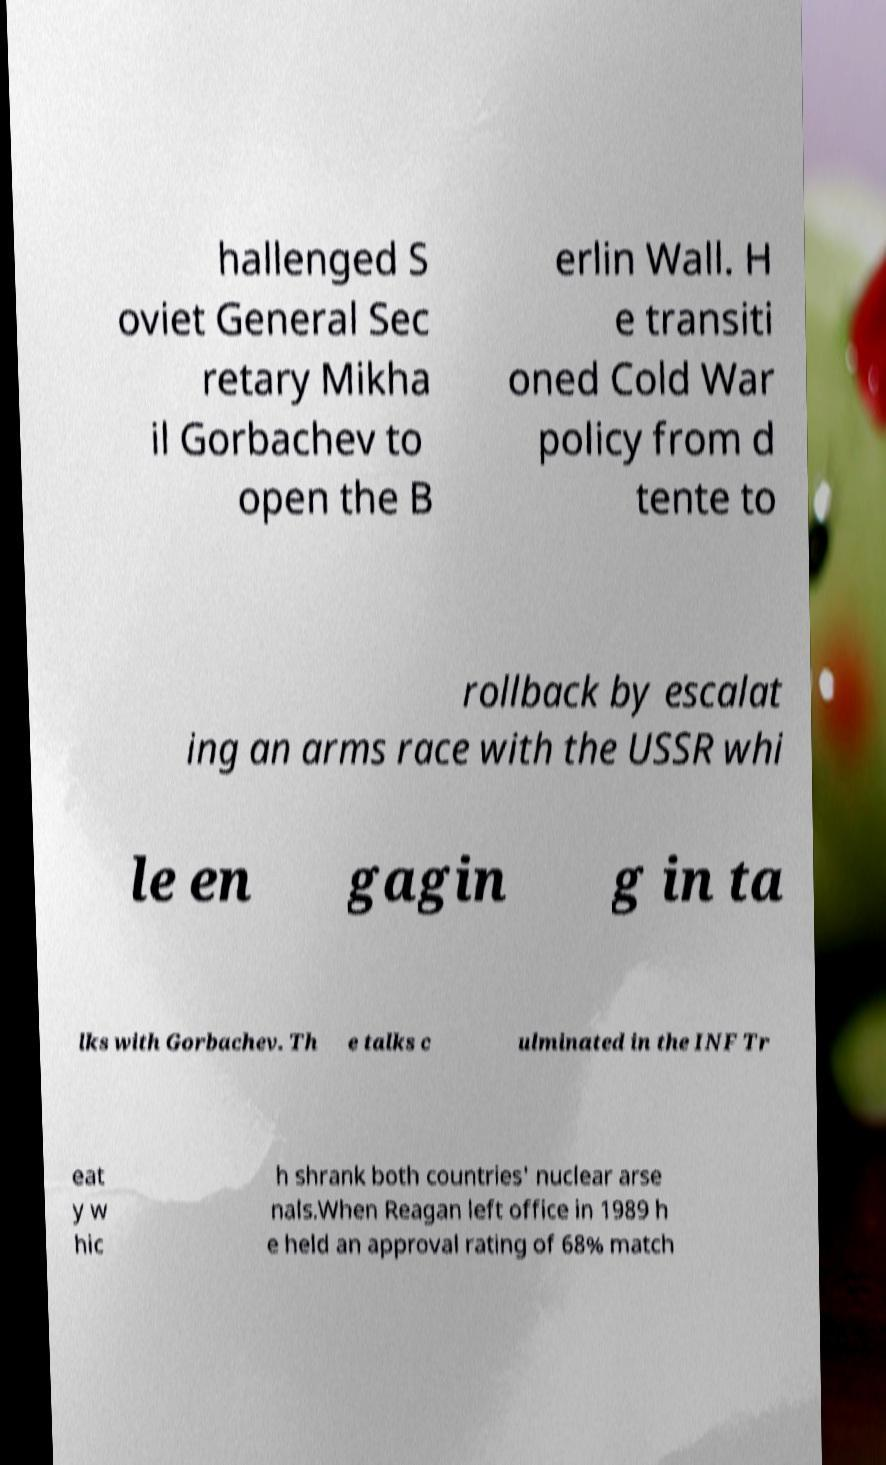Could you extract and type out the text from this image? hallenged S oviet General Sec retary Mikha il Gorbachev to open the B erlin Wall. H e transiti oned Cold War policy from d tente to rollback by escalat ing an arms race with the USSR whi le en gagin g in ta lks with Gorbachev. Th e talks c ulminated in the INF Tr eat y w hic h shrank both countries' nuclear arse nals.When Reagan left office in 1989 h e held an approval rating of 68% match 